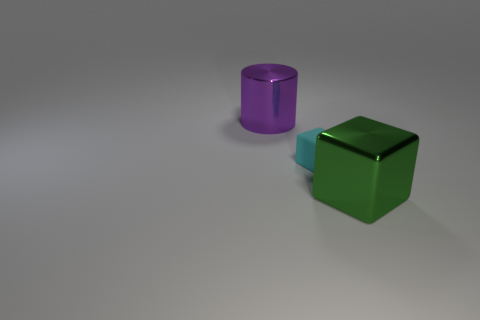Add 1 rubber blocks. How many objects exist? 4 Subtract all cylinders. How many objects are left? 2 Subtract 0 gray cylinders. How many objects are left? 3 Subtract all large metal cylinders. Subtract all big purple metal things. How many objects are left? 1 Add 2 purple metallic cylinders. How many purple metallic cylinders are left? 3 Add 3 small brown cylinders. How many small brown cylinders exist? 3 